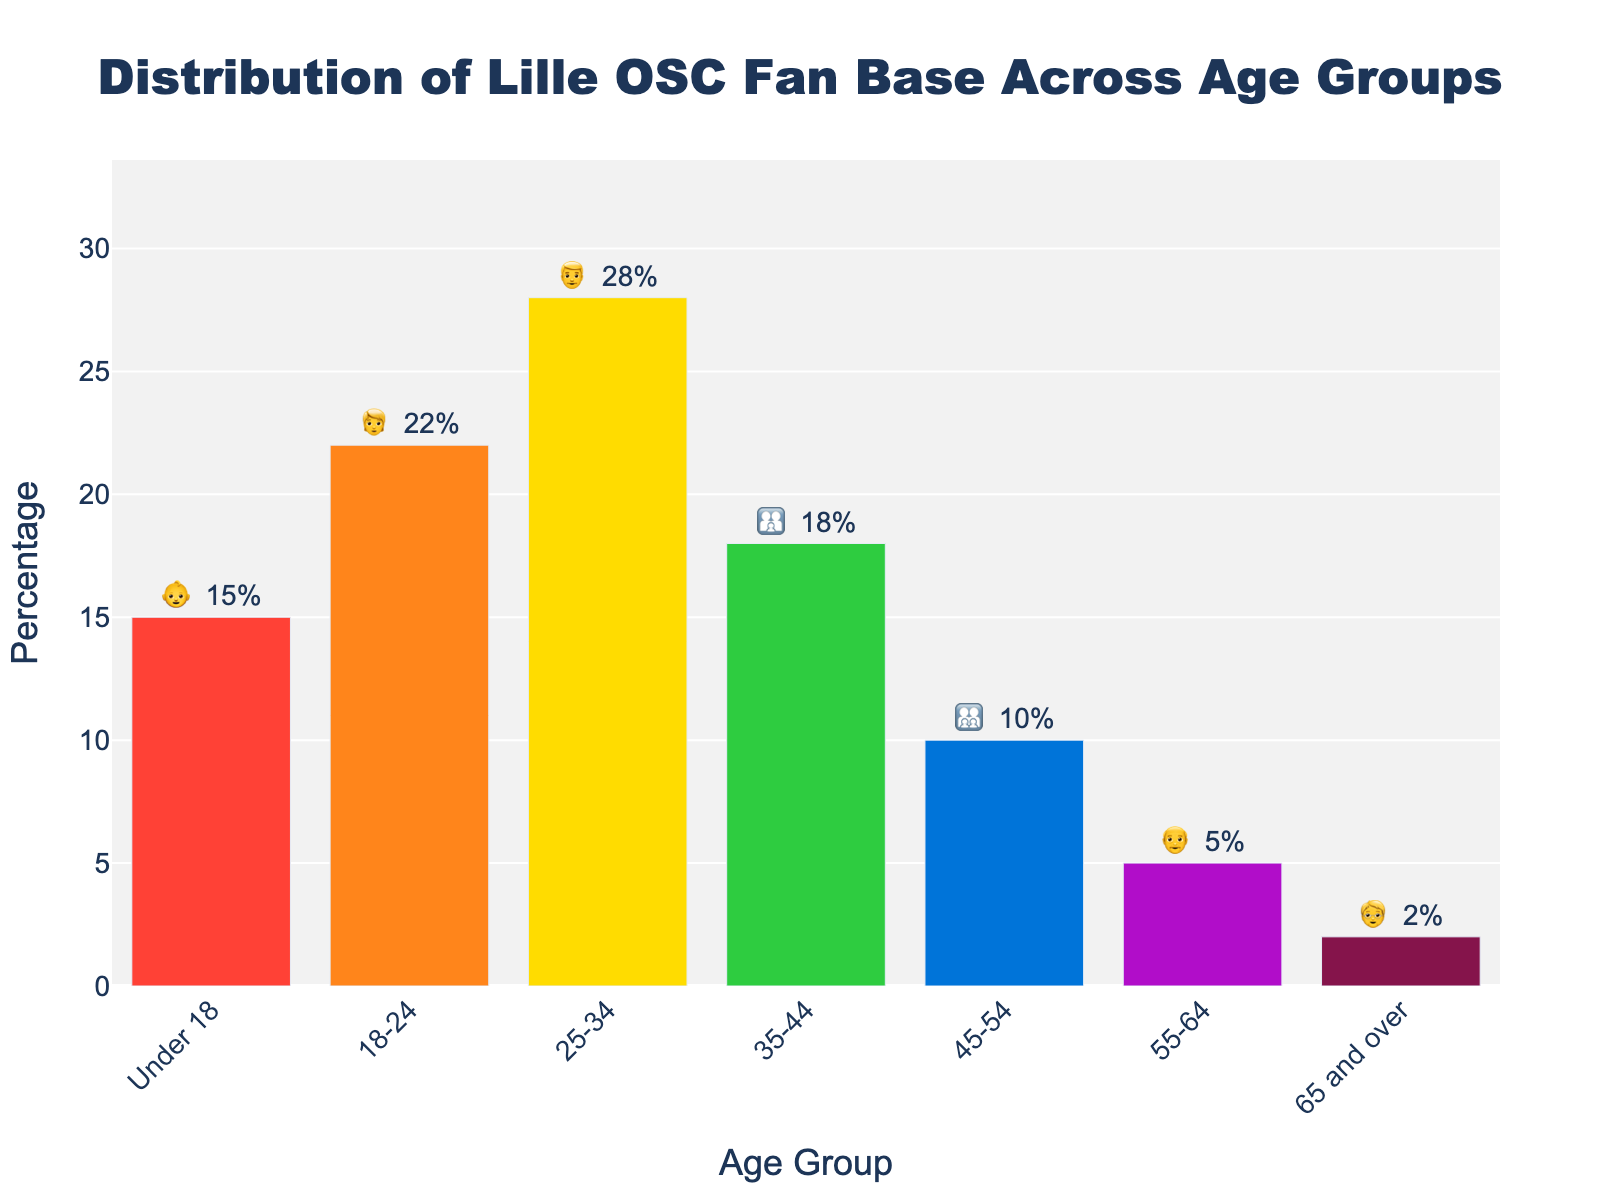What's the title of the figure? The title is located at the top of the plot and summarizes the main topic of the chart. It reads: "Distribution of Lille OSC Fan Base Across Age Groups".
Answer: Distribution of Lille OSC Fan Base Across Age Groups Which age group has the highest percentage of Lille OSC supporters? The bar with the highest value represents the age group with the highest percentage. Here, the tallest bar is labeled "25-34", indicating that this age group has the highest percentage.
Answer: 25-34 What is the percentage of Lille OSC supporters in the 'Under 18' age group? To find this, locate the bar labeled "Under 18" and check the percentage value in the text. The text shows "15%".
Answer: 15% How does the percentage of Lille OSC supporters in the '35-44' age group compare to the '45-54' age group? Compare the height and the percentage values of the bars labeled "35-44" and "45-54". The bar for "35-44" shows 18%, while "45-54" shows 10%.
Answer: 35-44 is higher What is the sum of the percentages of Lille OSC supporters aged '55-64' and '65 and over'? Add the percentage values of the bars labeled "55-64" and "65 and over". The values are 5% and 2% respectively. So, 5% + 2% = 7%.
Answer: 7% Which two age groups combined constitute more than 50% of the Lille OSC supporter base? Identify pairs of age groups whose combined percentages exceed 50%. The "25-34" group has 28% and "18-24" has 22%, together summing to 50%. Therefore, "25-34" (28%) and any additional group with more than 0% will exceed 50%.
Answer: 25-34 and 18-24 What is the difference in percentage between the 'Under 18' and '65 and over' age groups? Subtract the percentage of "65 and over" from the percentage of "Under 18". The values are 15% and 2%, respectively. So, 15% - 2% = 13%.
Answer: 13% Are there more Lille OSC supporters in the '25-34' age group or the combined '45-54' and '55-64' age groups? Compare the percentage of the "25-34" age group with the sum of the percentages of "45-54" and "55-64". "25-34" has 28%, while "45-54" (10%) + "55-64" (5%) equals 15%. So, 28% > 15%.
Answer: 25-34 Is there any age group with less than 5% of Lille OSC supporters? Check all the bar values to see if any of them are below 5%. The bar labeled "65 and over" shows 2%.
Answer: Yes, 65 and over 